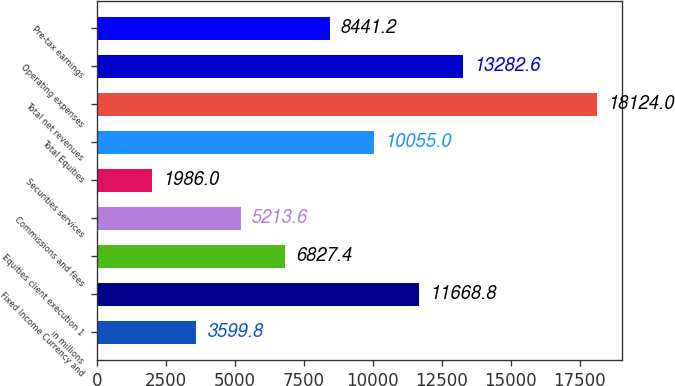Convert chart. <chart><loc_0><loc_0><loc_500><loc_500><bar_chart><fcel>in millions<fcel>Fixed Income Currency and<fcel>Equities client execution 1<fcel>Commissions and fees<fcel>Securities services<fcel>Total Equities<fcel>Total net revenues<fcel>Operating expenses<fcel>Pre-tax earnings<nl><fcel>3599.8<fcel>11668.8<fcel>6827.4<fcel>5213.6<fcel>1986<fcel>10055<fcel>18124<fcel>13282.6<fcel>8441.2<nl></chart> 